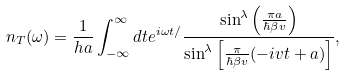<formula> <loc_0><loc_0><loc_500><loc_500>n _ { T } ( \omega ) = \frac { 1 } { h a } \int _ { - \infty } ^ { \infty } d t e ^ { i \omega t / } \frac { \sin ^ { \lambda } \left ( \frac { \pi a } { \hbar { \beta } v } \right ) } { \sin ^ { \lambda } \left [ \frac { \pi } { \hbar { \beta } v } ( - i v t + a ) \right ] } ,</formula> 